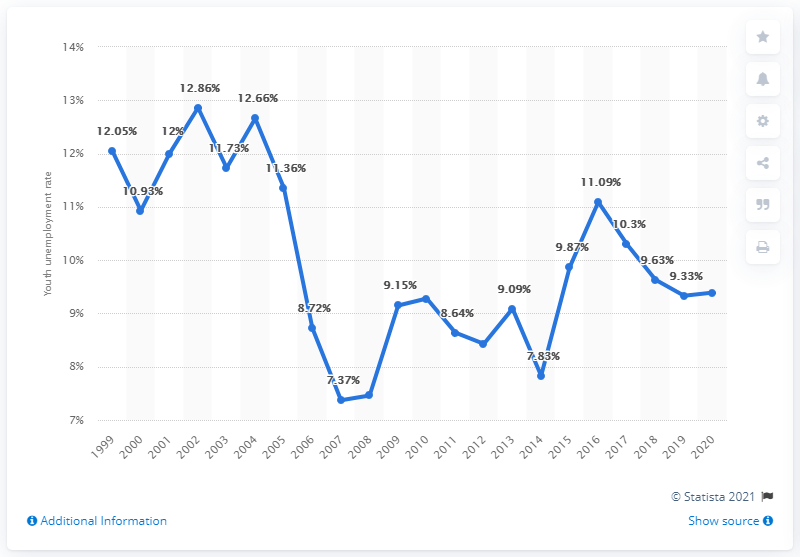What factors could have influenced the sharp decrease in youth unemployment from 2002 to 2008? Multiple factors could have contributed to the decrease in Norway's youth unemployment from 2002 to 2008, such as economic growth, job creation policies targeting the youth, improvements in the education system aligning better with labor market needs, and possibly favorable changes in the global economy that increased demand for Norwegian goods and services. 